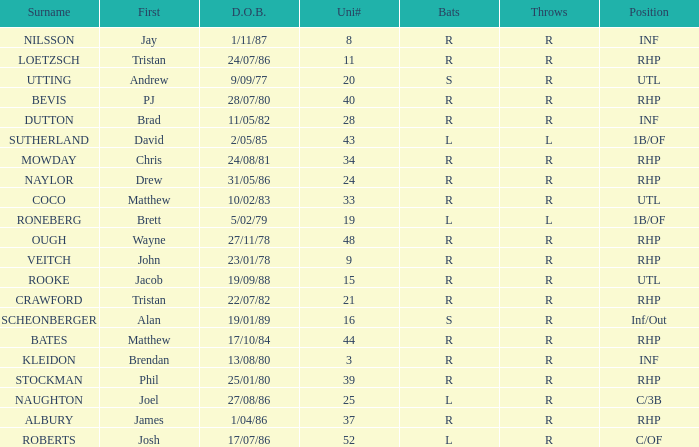How many Uni numbers have Bats of s, and a Position of utl? 1.0. 